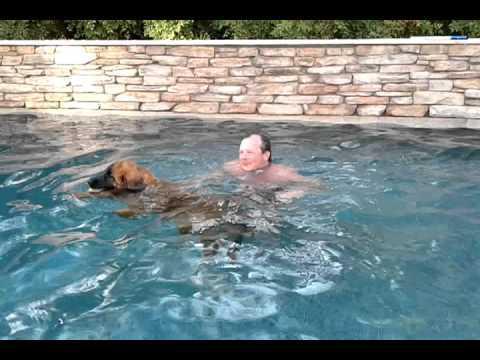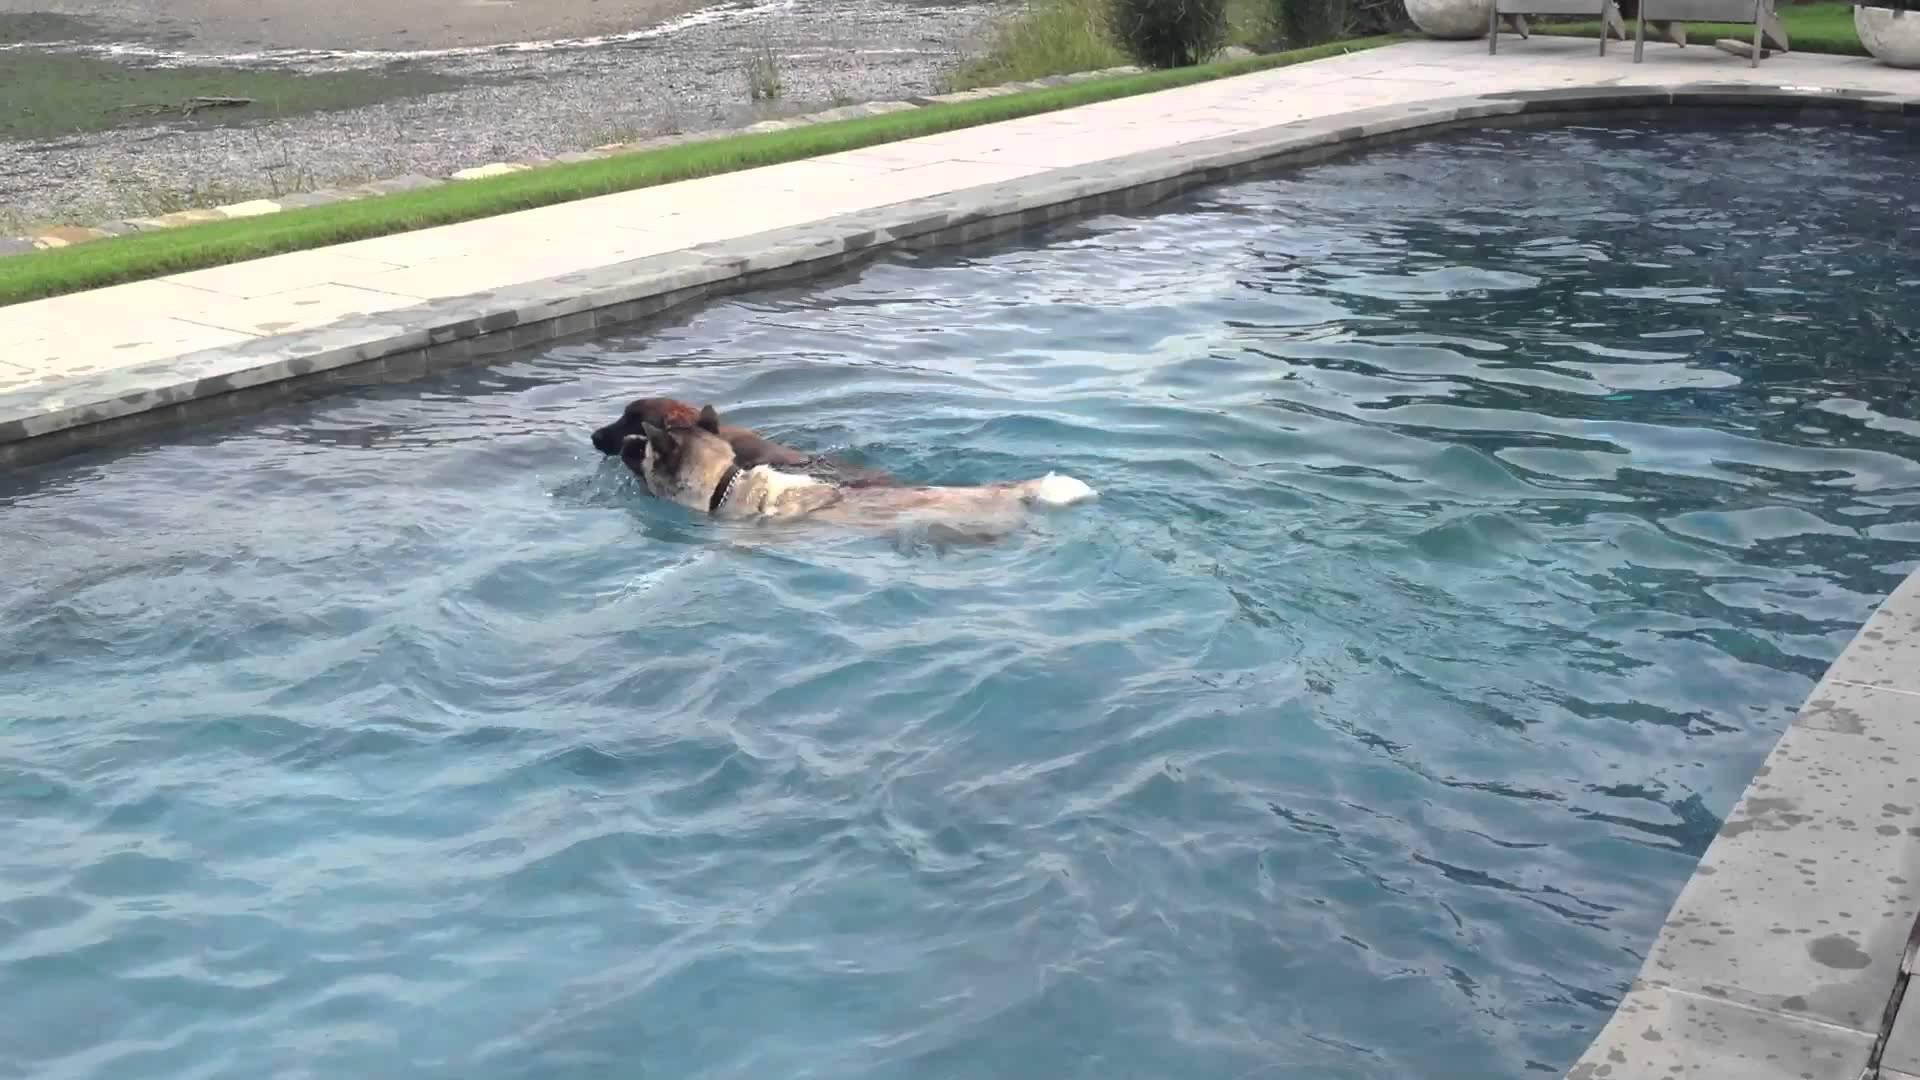The first image is the image on the left, the second image is the image on the right. For the images shown, is this caption "Two dog are in a natural body of water." true? Answer yes or no. No. 